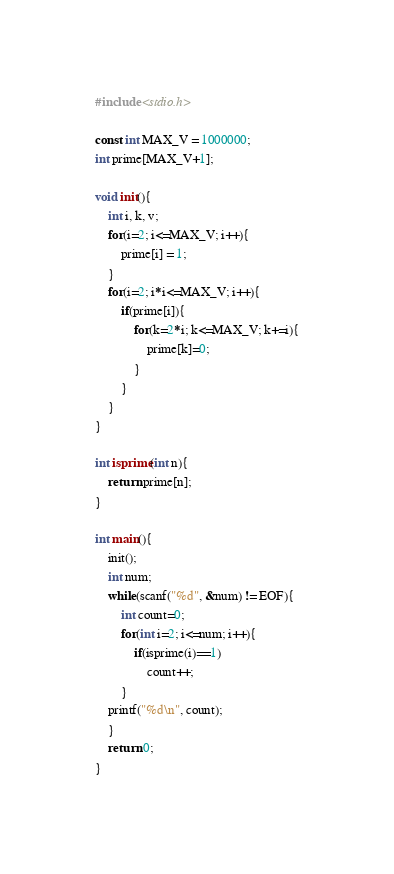Convert code to text. <code><loc_0><loc_0><loc_500><loc_500><_C_>#include <stdio.h>

const int MAX_V = 1000000;
int prime[MAX_V+1];

void init(){
    int i, k, v;
    for(i=2; i<=MAX_V; i++){
        prime[i] = 1;
    }
    for(i=2; i*i<=MAX_V; i++){
        if(prime[i]){
            for(k=2*i; k<=MAX_V; k+=i){
                prime[k]=0;
            }
        }
    }   
}

int isprime(int n){
    return prime[n];
}

int main(){
    init();
    int num;
    while(scanf("%d", &num) != EOF){
        int count=0;
        for(int i=2; i<=num; i++){
            if(isprime(i)==1)
                count++;
        }
    printf("%d\n", count);
    }
    return 0;
}</code> 